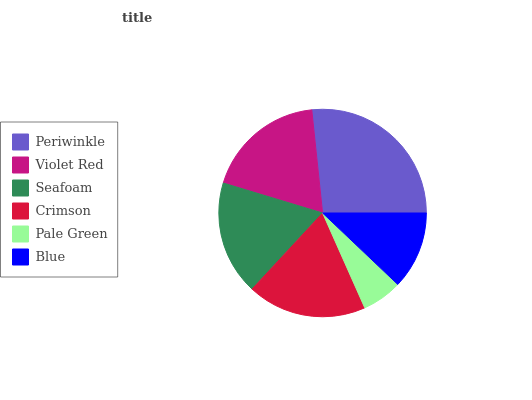Is Pale Green the minimum?
Answer yes or no. Yes. Is Periwinkle the maximum?
Answer yes or no. Yes. Is Violet Red the minimum?
Answer yes or no. No. Is Violet Red the maximum?
Answer yes or no. No. Is Periwinkle greater than Violet Red?
Answer yes or no. Yes. Is Violet Red less than Periwinkle?
Answer yes or no. Yes. Is Violet Red greater than Periwinkle?
Answer yes or no. No. Is Periwinkle less than Violet Red?
Answer yes or no. No. Is Crimson the high median?
Answer yes or no. Yes. Is Seafoam the low median?
Answer yes or no. Yes. Is Violet Red the high median?
Answer yes or no. No. Is Pale Green the low median?
Answer yes or no. No. 